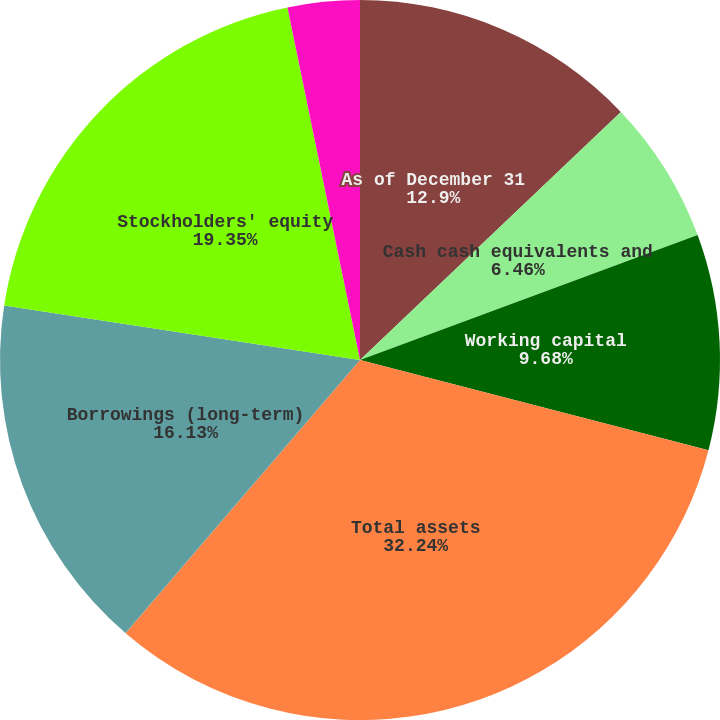Convert chart. <chart><loc_0><loc_0><loc_500><loc_500><pie_chart><fcel>As of December 31<fcel>Cash cash equivalents and<fcel>Working capital<fcel>Total assets<fcel>Borrowings (short-term)<fcel>Borrowings (long-term)<fcel>Stockholders' equity<fcel>Book value per common share<nl><fcel>12.9%<fcel>6.46%<fcel>9.68%<fcel>32.25%<fcel>0.01%<fcel>16.13%<fcel>19.35%<fcel>3.23%<nl></chart> 